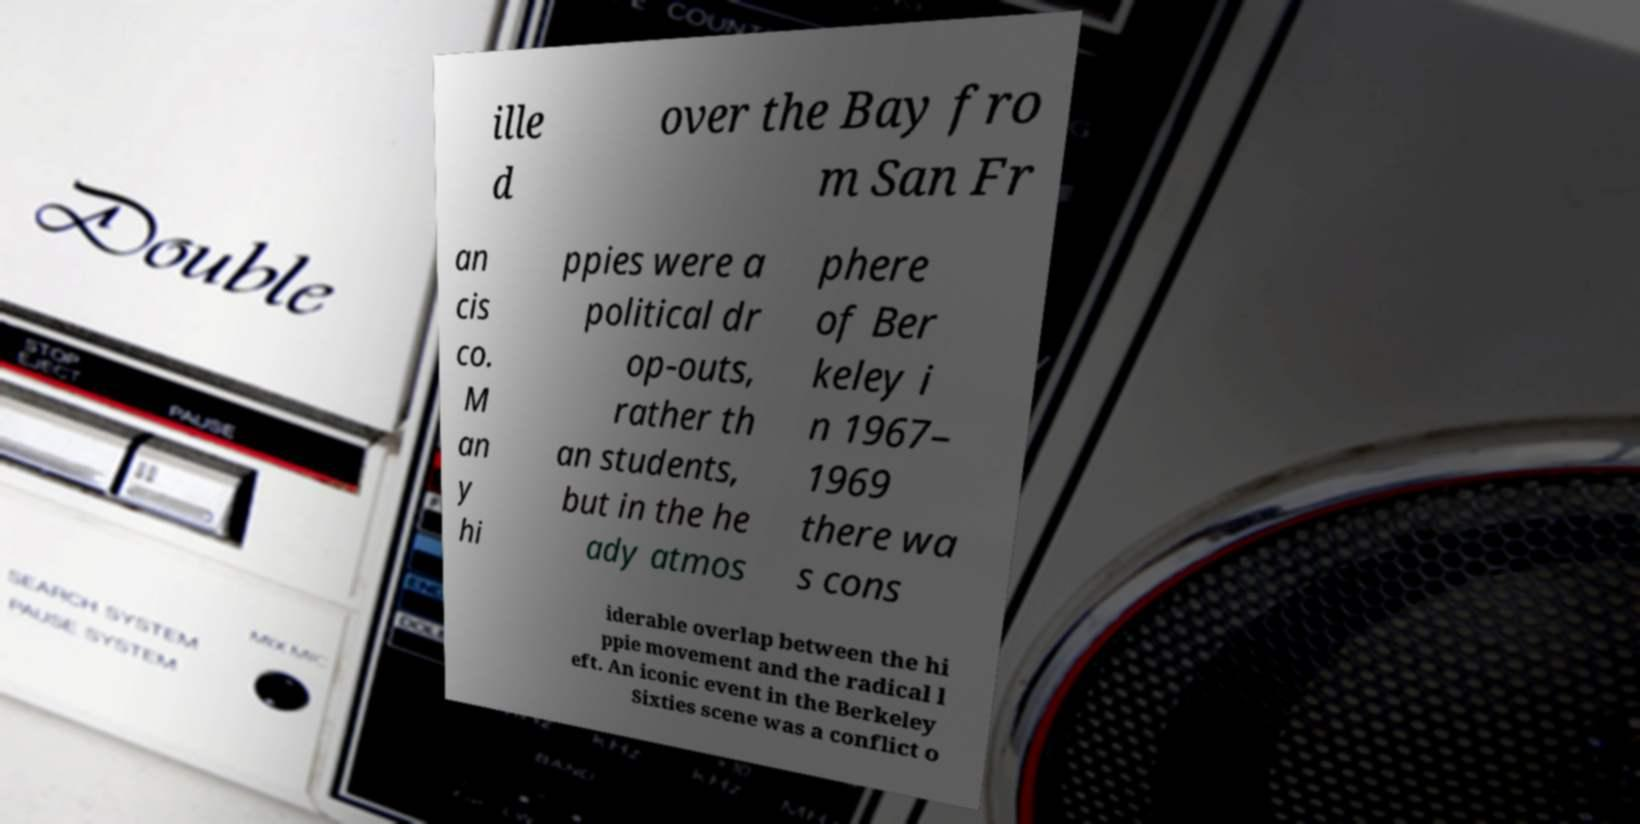Could you assist in decoding the text presented in this image and type it out clearly? ille d over the Bay fro m San Fr an cis co. M an y hi ppies were a political dr op-outs, rather th an students, but in the he ady atmos phere of Ber keley i n 1967– 1969 there wa s cons iderable overlap between the hi ppie movement and the radical l eft. An iconic event in the Berkeley Sixties scene was a conflict o 